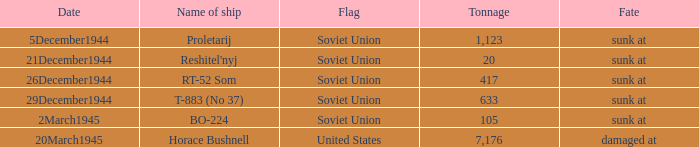How did the ship named proletarij finish its service? Sunk at. 